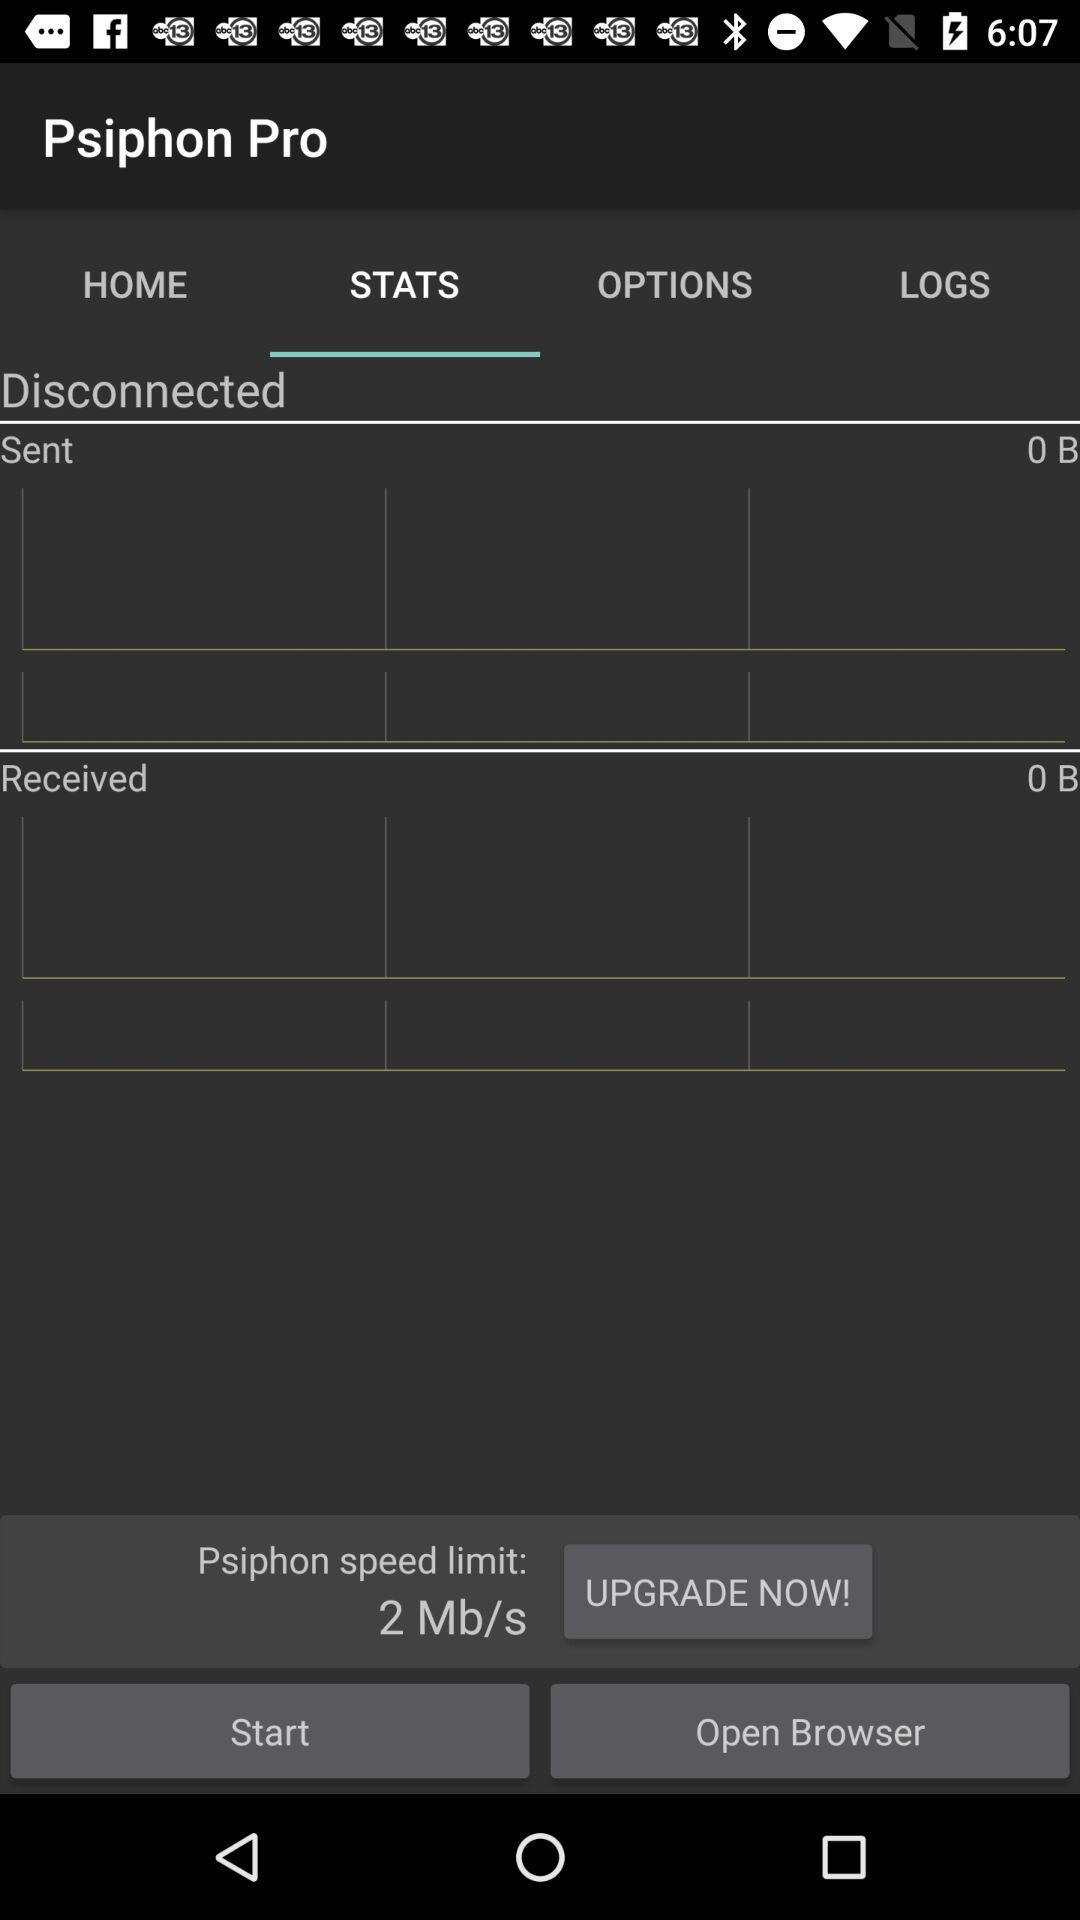How much data have I received?
Answer the question using a single word or phrase. 0 B 